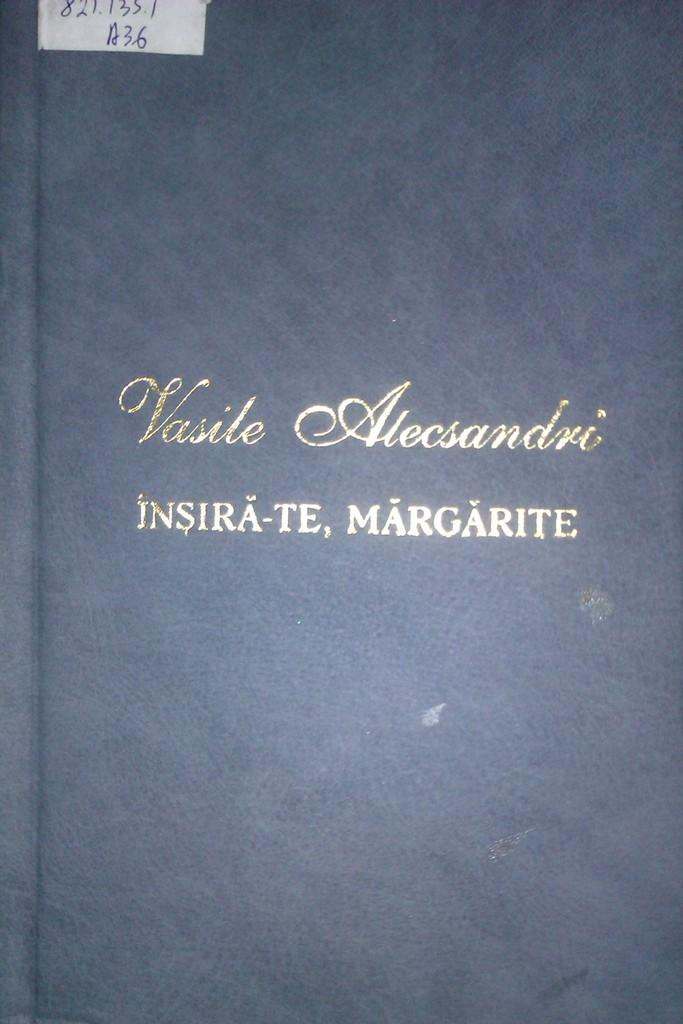<image>
Describe the image concisely. a book that has vasile on the cover of it 